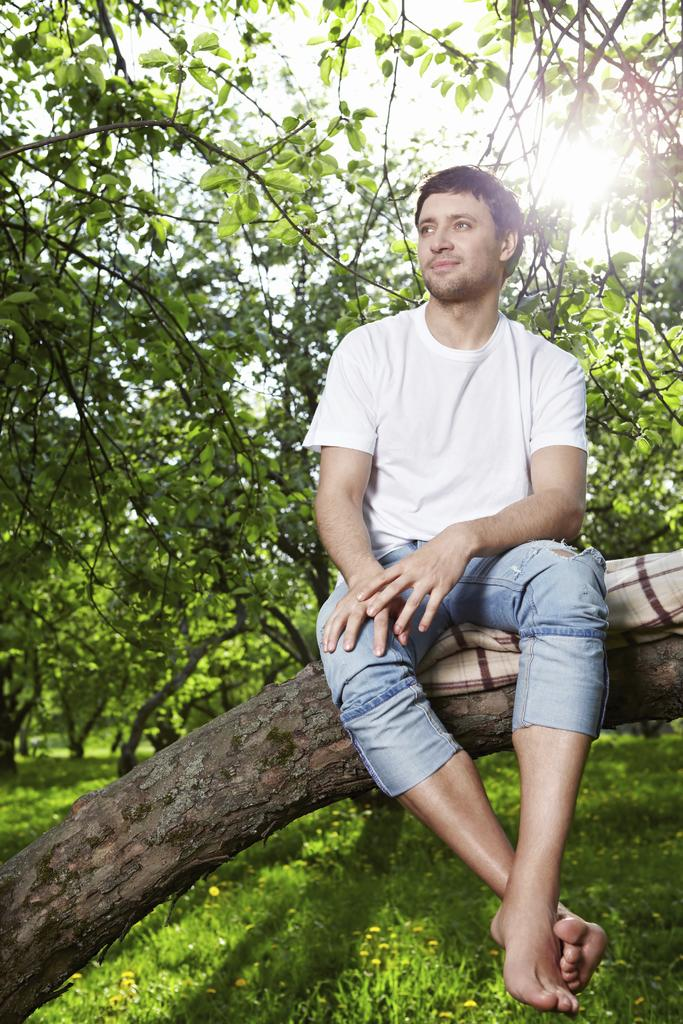What is the person in the image sitting on? The person is sitting on a tree trunk in the image. What is placed under the person? There is a cloth under the person. What can be seen in the background of the image? There are trees in the background of the image. What type of vegetation is visible at the bottom of the image? There are plants at the bottom of the image. What type of legal advice is the person seeking in the image? There is no lawyer or legal advice present in the image; it features a person sitting on a tree trunk with a cloth underneath. 